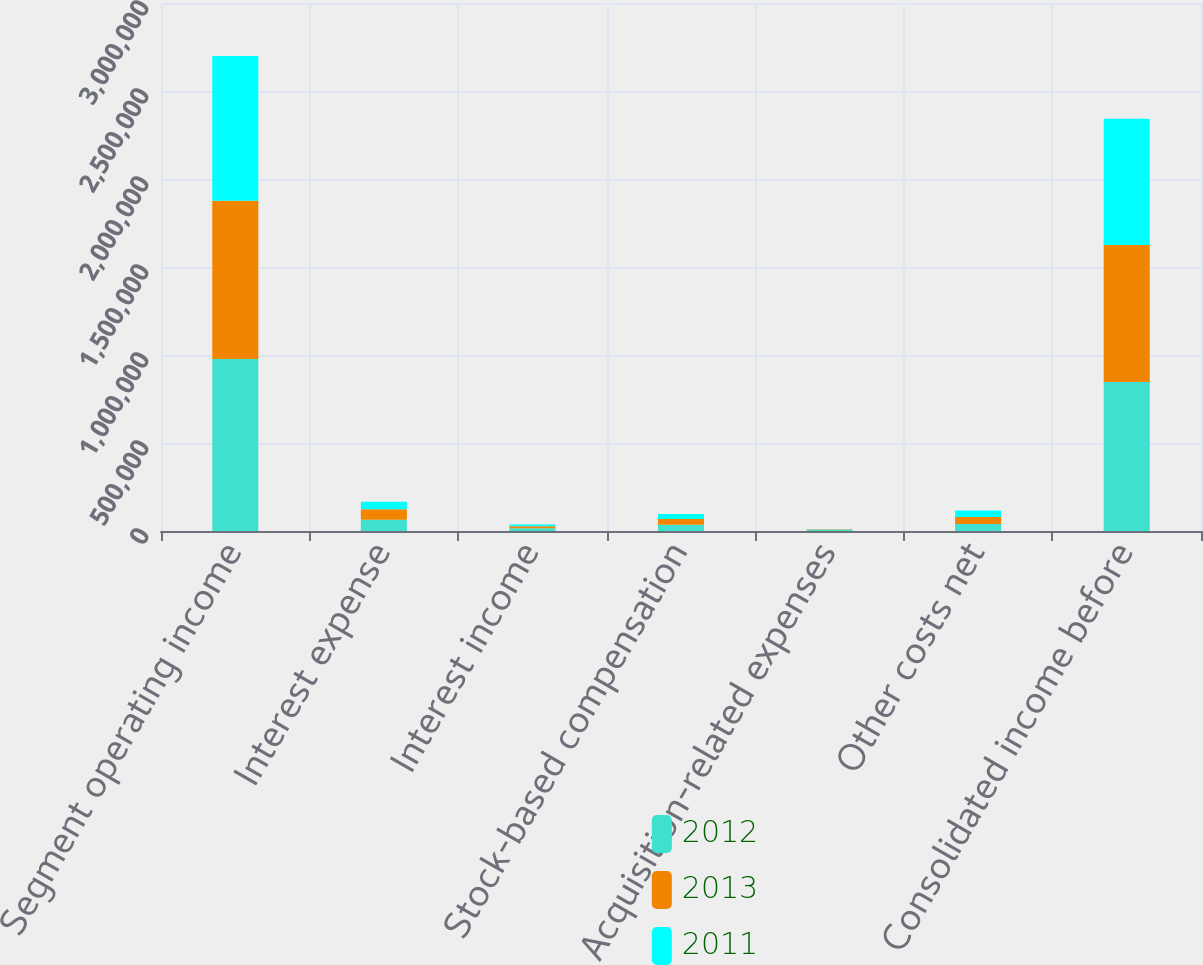<chart> <loc_0><loc_0><loc_500><loc_500><stacked_bar_chart><ecel><fcel>Segment operating income<fcel>Interest expense<fcel>Interest income<fcel>Stock-based compensation<fcel>Acquisition-related expenses<fcel>Other costs net<fcel>Consolidated income before<nl><fcel>2012<fcel>977357<fcel>63553<fcel>14972<fcel>36070<fcel>5983<fcel>40078<fcel>846645<nl><fcel>2013<fcel>899205<fcel>59613<fcel>11512<fcel>31412<fcel>2000<fcel>38851<fcel>778841<nl><fcel>2011<fcel>822136<fcel>43029<fcel>10245<fcel>28679<fcel>2000<fcel>38255<fcel>716752<nl></chart> 